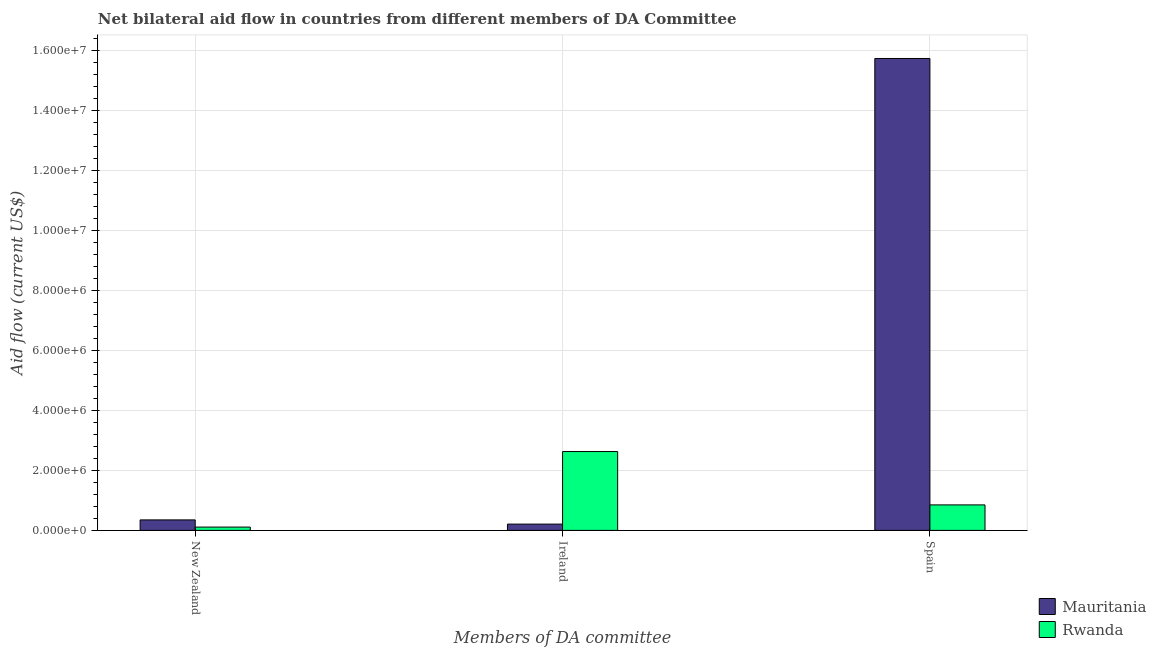How many bars are there on the 1st tick from the left?
Make the answer very short. 2. How many bars are there on the 2nd tick from the right?
Your response must be concise. 2. What is the label of the 1st group of bars from the left?
Offer a very short reply. New Zealand. What is the amount of aid provided by new zealand in Rwanda?
Your answer should be very brief. 1.10e+05. Across all countries, what is the maximum amount of aid provided by spain?
Provide a short and direct response. 1.57e+07. Across all countries, what is the minimum amount of aid provided by new zealand?
Your response must be concise. 1.10e+05. In which country was the amount of aid provided by ireland maximum?
Provide a short and direct response. Rwanda. In which country was the amount of aid provided by ireland minimum?
Offer a very short reply. Mauritania. What is the total amount of aid provided by spain in the graph?
Make the answer very short. 1.66e+07. What is the difference between the amount of aid provided by ireland in Mauritania and that in Rwanda?
Your response must be concise. -2.42e+06. What is the difference between the amount of aid provided by ireland in Mauritania and the amount of aid provided by spain in Rwanda?
Your answer should be compact. -6.40e+05. What is the average amount of aid provided by ireland per country?
Your answer should be compact. 1.42e+06. What is the difference between the amount of aid provided by ireland and amount of aid provided by spain in Rwanda?
Provide a succinct answer. 1.78e+06. What is the ratio of the amount of aid provided by ireland in Rwanda to that in Mauritania?
Your answer should be very brief. 12.52. Is the difference between the amount of aid provided by ireland in Rwanda and Mauritania greater than the difference between the amount of aid provided by spain in Rwanda and Mauritania?
Make the answer very short. Yes. What is the difference between the highest and the second highest amount of aid provided by spain?
Ensure brevity in your answer.  1.49e+07. What is the difference between the highest and the lowest amount of aid provided by ireland?
Give a very brief answer. 2.42e+06. Is the sum of the amount of aid provided by spain in Mauritania and Rwanda greater than the maximum amount of aid provided by ireland across all countries?
Your answer should be compact. Yes. What does the 2nd bar from the left in Ireland represents?
Provide a succinct answer. Rwanda. What does the 2nd bar from the right in Spain represents?
Keep it short and to the point. Mauritania. Is it the case that in every country, the sum of the amount of aid provided by new zealand and amount of aid provided by ireland is greater than the amount of aid provided by spain?
Provide a succinct answer. No. How many bars are there?
Give a very brief answer. 6. Are all the bars in the graph horizontal?
Give a very brief answer. No. Does the graph contain any zero values?
Make the answer very short. No. Does the graph contain grids?
Make the answer very short. Yes. How many legend labels are there?
Your response must be concise. 2. How are the legend labels stacked?
Offer a very short reply. Vertical. What is the title of the graph?
Make the answer very short. Net bilateral aid flow in countries from different members of DA Committee. Does "Guatemala" appear as one of the legend labels in the graph?
Ensure brevity in your answer.  No. What is the label or title of the X-axis?
Ensure brevity in your answer.  Members of DA committee. What is the Aid flow (current US$) in Mauritania in New Zealand?
Make the answer very short. 3.50e+05. What is the Aid flow (current US$) in Rwanda in Ireland?
Give a very brief answer. 2.63e+06. What is the Aid flow (current US$) in Mauritania in Spain?
Keep it short and to the point. 1.57e+07. What is the Aid flow (current US$) of Rwanda in Spain?
Your answer should be compact. 8.50e+05. Across all Members of DA committee, what is the maximum Aid flow (current US$) in Mauritania?
Your answer should be compact. 1.57e+07. Across all Members of DA committee, what is the maximum Aid flow (current US$) of Rwanda?
Provide a succinct answer. 2.63e+06. Across all Members of DA committee, what is the minimum Aid flow (current US$) of Mauritania?
Offer a terse response. 2.10e+05. What is the total Aid flow (current US$) of Mauritania in the graph?
Keep it short and to the point. 1.63e+07. What is the total Aid flow (current US$) in Rwanda in the graph?
Offer a very short reply. 3.59e+06. What is the difference between the Aid flow (current US$) of Mauritania in New Zealand and that in Ireland?
Make the answer very short. 1.40e+05. What is the difference between the Aid flow (current US$) of Rwanda in New Zealand and that in Ireland?
Keep it short and to the point. -2.52e+06. What is the difference between the Aid flow (current US$) of Mauritania in New Zealand and that in Spain?
Your answer should be very brief. -1.54e+07. What is the difference between the Aid flow (current US$) in Rwanda in New Zealand and that in Spain?
Ensure brevity in your answer.  -7.40e+05. What is the difference between the Aid flow (current US$) of Mauritania in Ireland and that in Spain?
Keep it short and to the point. -1.55e+07. What is the difference between the Aid flow (current US$) of Rwanda in Ireland and that in Spain?
Ensure brevity in your answer.  1.78e+06. What is the difference between the Aid flow (current US$) of Mauritania in New Zealand and the Aid flow (current US$) of Rwanda in Ireland?
Offer a terse response. -2.28e+06. What is the difference between the Aid flow (current US$) of Mauritania in New Zealand and the Aid flow (current US$) of Rwanda in Spain?
Your answer should be compact. -5.00e+05. What is the difference between the Aid flow (current US$) in Mauritania in Ireland and the Aid flow (current US$) in Rwanda in Spain?
Make the answer very short. -6.40e+05. What is the average Aid flow (current US$) of Mauritania per Members of DA committee?
Keep it short and to the point. 5.43e+06. What is the average Aid flow (current US$) in Rwanda per Members of DA committee?
Provide a succinct answer. 1.20e+06. What is the difference between the Aid flow (current US$) of Mauritania and Aid flow (current US$) of Rwanda in New Zealand?
Offer a very short reply. 2.40e+05. What is the difference between the Aid flow (current US$) in Mauritania and Aid flow (current US$) in Rwanda in Ireland?
Provide a succinct answer. -2.42e+06. What is the difference between the Aid flow (current US$) in Mauritania and Aid flow (current US$) in Rwanda in Spain?
Ensure brevity in your answer.  1.49e+07. What is the ratio of the Aid flow (current US$) in Mauritania in New Zealand to that in Ireland?
Your answer should be very brief. 1.67. What is the ratio of the Aid flow (current US$) of Rwanda in New Zealand to that in Ireland?
Make the answer very short. 0.04. What is the ratio of the Aid flow (current US$) in Mauritania in New Zealand to that in Spain?
Keep it short and to the point. 0.02. What is the ratio of the Aid flow (current US$) in Rwanda in New Zealand to that in Spain?
Your response must be concise. 0.13. What is the ratio of the Aid flow (current US$) in Mauritania in Ireland to that in Spain?
Your response must be concise. 0.01. What is the ratio of the Aid flow (current US$) in Rwanda in Ireland to that in Spain?
Your response must be concise. 3.09. What is the difference between the highest and the second highest Aid flow (current US$) in Mauritania?
Ensure brevity in your answer.  1.54e+07. What is the difference between the highest and the second highest Aid flow (current US$) of Rwanda?
Make the answer very short. 1.78e+06. What is the difference between the highest and the lowest Aid flow (current US$) in Mauritania?
Make the answer very short. 1.55e+07. What is the difference between the highest and the lowest Aid flow (current US$) of Rwanda?
Ensure brevity in your answer.  2.52e+06. 